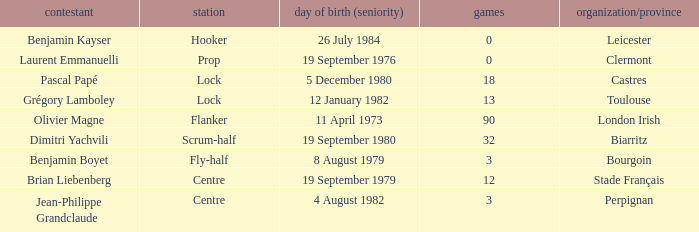What is the birthday of caps of 32? 19 September 1980. 